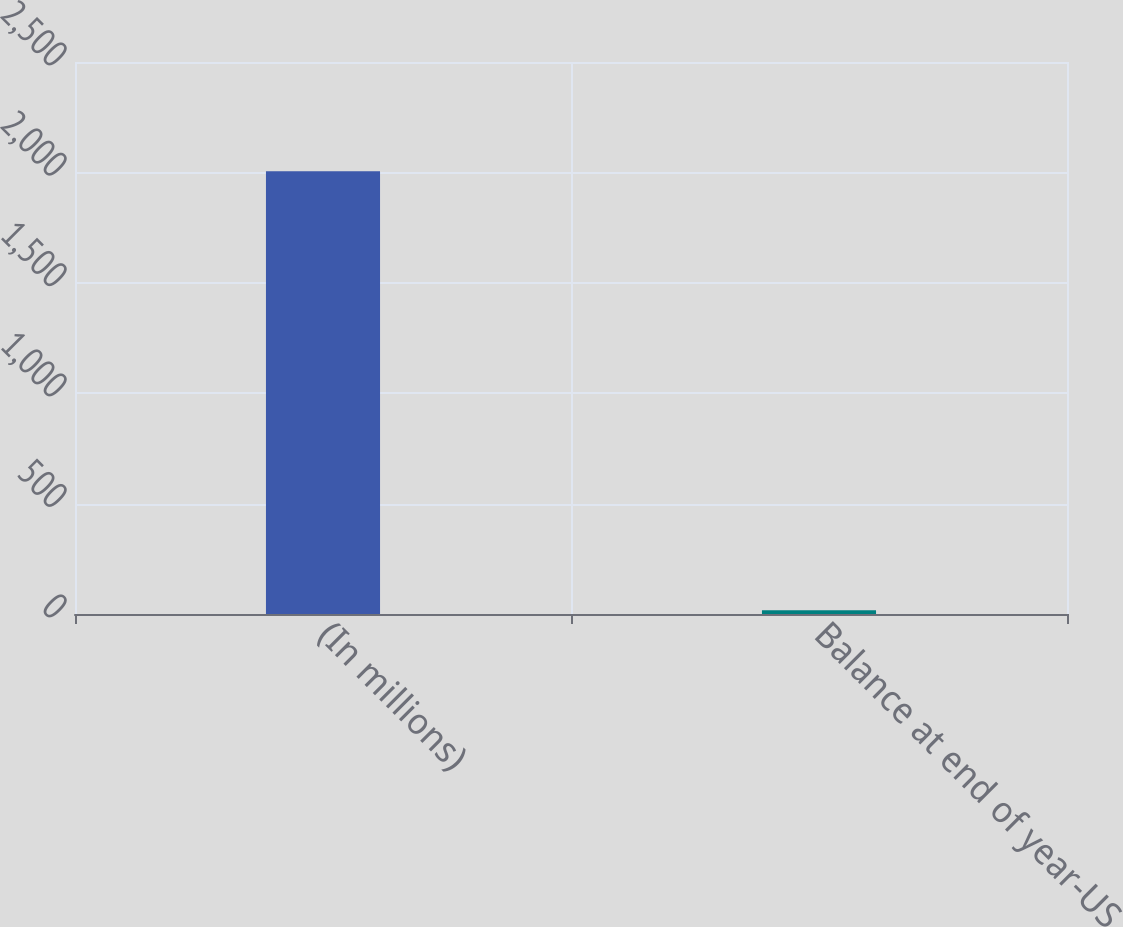Convert chart to OTSL. <chart><loc_0><loc_0><loc_500><loc_500><bar_chart><fcel>(In millions)<fcel>Balance at end of year-US<nl><fcel>2005<fcel>17<nl></chart> 